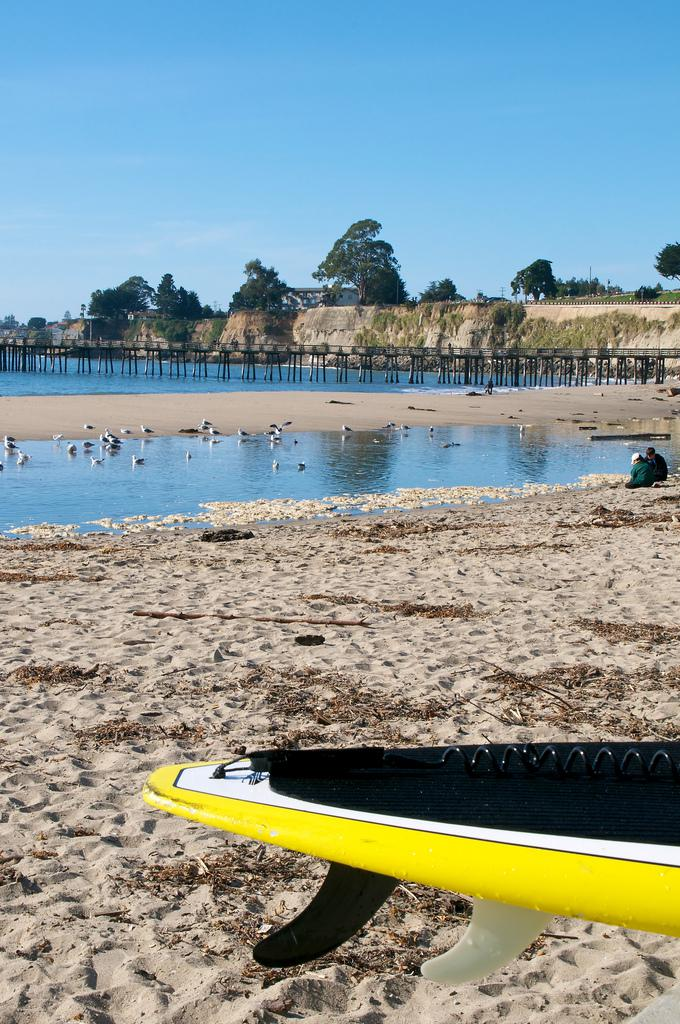Question: what does the sand have?
Choices:
A. A lot of debris.
B. Trash.
C. Grass.
D. Weeds.
Answer with the letter. Answer: A Question: where is the driftwood?
Choices:
A. On the beach.
B. Floating in the water.
C. Near the rock.
D. By the blanket.
Answer with the letter. Answer: A Question: what is in the water?
Choices:
A. Birds.
B. Fish eating.
C. An empty water bottle.
D. Rocks.
Answer with the letter. Answer: A Question: where is it waveless?
Choices:
A. The mountains.
B. The city.
C. The beach.
D. The park.
Answer with the letter. Answer: C Question: who is near the surfboard?
Choices:
A. The man.
B. The surfer.
C. None.
D. The teenager.
Answer with the letter. Answer: C Question: what are full of foliage?
Choices:
A. The bushes.
B. The trees.
C. The garden.
D. The woods.
Answer with the letter. Answer: B Question: who uses a surfboard?
Choices:
A. A surfer.
B. A woman.
C. A man.
D. A dog.
Answer with the letter. Answer: A Question: what are the birds doing?
Choices:
A. Trying to catch a piece of bread.
B. Singing.
C. Swimming in the water.
D. Watching the hawk.
Answer with the letter. Answer: C Question: how many people are here?
Choices:
A. 2.
B. A lot.
C. It's a packed house.
D. It's a full room.
Answer with the letter. Answer: A Question: why are the people sitting?
Choices:
A. They are tired.
B. It's lunch time.
C. Looking at the water.
D. It's break time.
Answer with the letter. Answer: C Question: where is this picture taken?
Choices:
A. In Hawaii.
B. At the beach.
C. At the party.
D. At the carnival.
Answer with the letter. Answer: B Question: how did the pool of water get created?
Choices:
A. Water system.
B. By the outgoing tide.
C. Rain.
D. Rivers.
Answer with the letter. Answer: B Question: what are the birds wading in?
Choices:
A. Water.
B. Mud.
C. Ocean.
D. Rivers.
Answer with the letter. Answer: A Question: what has washed upon the shore?
Choices:
A. Seaweed.
B. Shells.
C. A fish.
D. An octopus.
Answer with the letter. Answer: A Question: what looks black?
Choices:
A. The sky.
B. The water.
C. The bridge.
D. The buildings.
Answer with the letter. Answer: C 